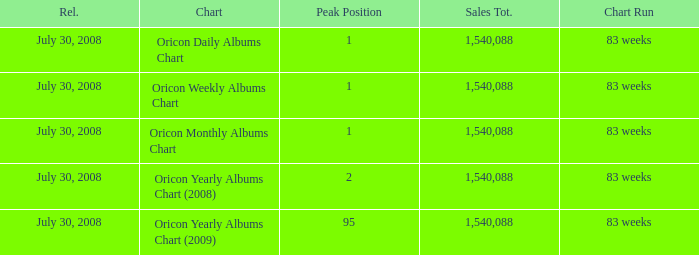Which Chart has a Peak Position of 1? Oricon Daily Albums Chart, Oricon Weekly Albums Chart, Oricon Monthly Albums Chart. 